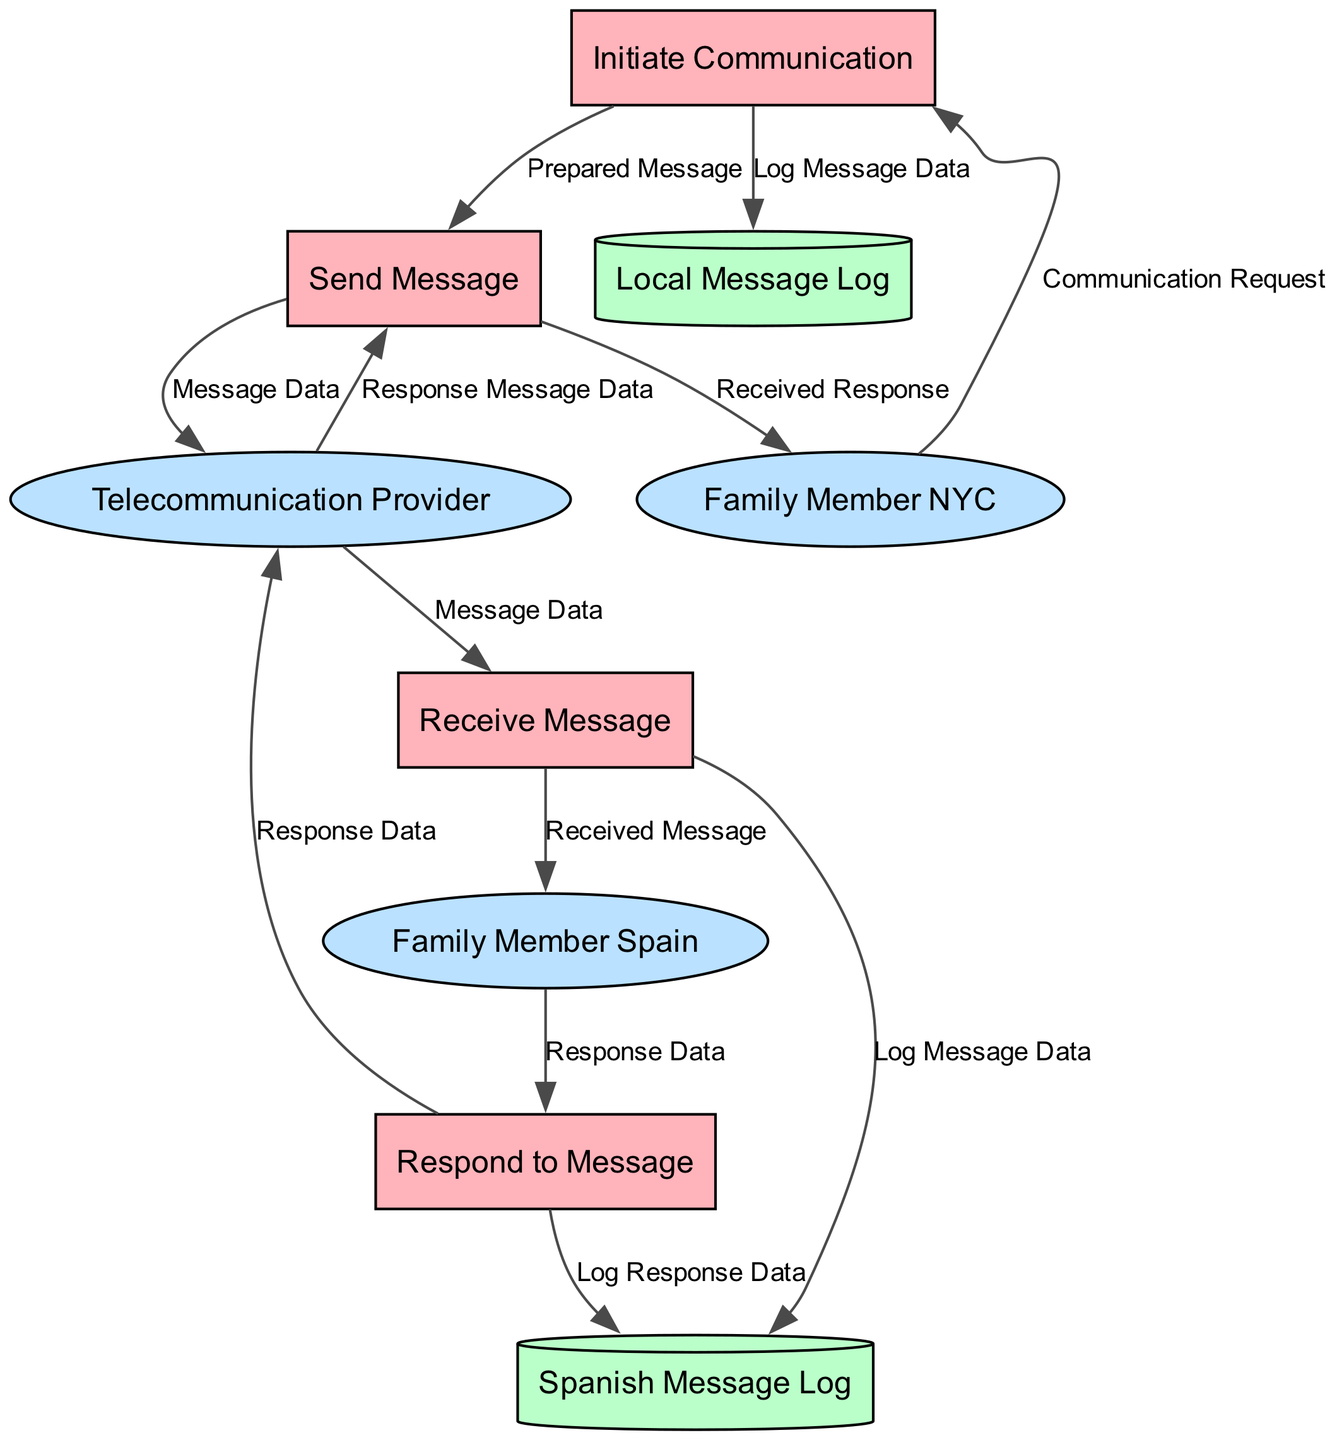What is the name of the first process? The diagram indicates that the first process is named 'Initiate Communication'. It's explicitly labeled as the starting point for the communication chain.
Answer: Initiate Communication How many data stores are present in the diagram? By examining the diagram, we can see there are two data stores labeled as 'Local Message Log' and 'Spanish Message Log'. Therefore, the total count is two.
Answer: 2 Who is the external entity located in Spain? Looking at the external entities, the one associated with Spain is labeled 'Family Member Spain', indicating the family member who resides in that country.
Answer: Family Member Spain What does the 'Send Message' process send to the telecommunication provider? The 'Send Message' process sends 'Message Data' to the telecommunication provider, as specified in the data flow description connecting these two elements.
Answer: Message Data Which process does 'Response Data' originate from? Following the flow of the data, 'Response Data' originates from the 'Respond to Message' process, which indicates a response being crafted by the family member in Spain.
Answer: Respond to Message What data is logged in the 'Spanish Message Log'? The 'Spanish Message Log' logs both 'Log Message Data' and 'Log Response Data', based on connections from the 'Receive Message' and 'Respond to Message' processes respectively.
Answer: Log Message Data and Log Response Data How many total flows are shown in the diagram? By counting the connections, we find there are twelve data flows detailed in the diagram, illustrating the pathways of data transfer between processes and entities.
Answer: 12 What is the final destination of the 'Response Message Data'? Tracing the flow, 'Response Message Data' is ultimately sent to the 'Family Member NYC', which indicates that the response from Spain gets delivered back to the originating family member.
Answer: Family Member NYC Which process comes after 'Receive Message'? After 'Receive Message', the next process identified in the flow is 'Respond to Message', where the family member in Spain will reply to the received communication.
Answer: Respond to Message 